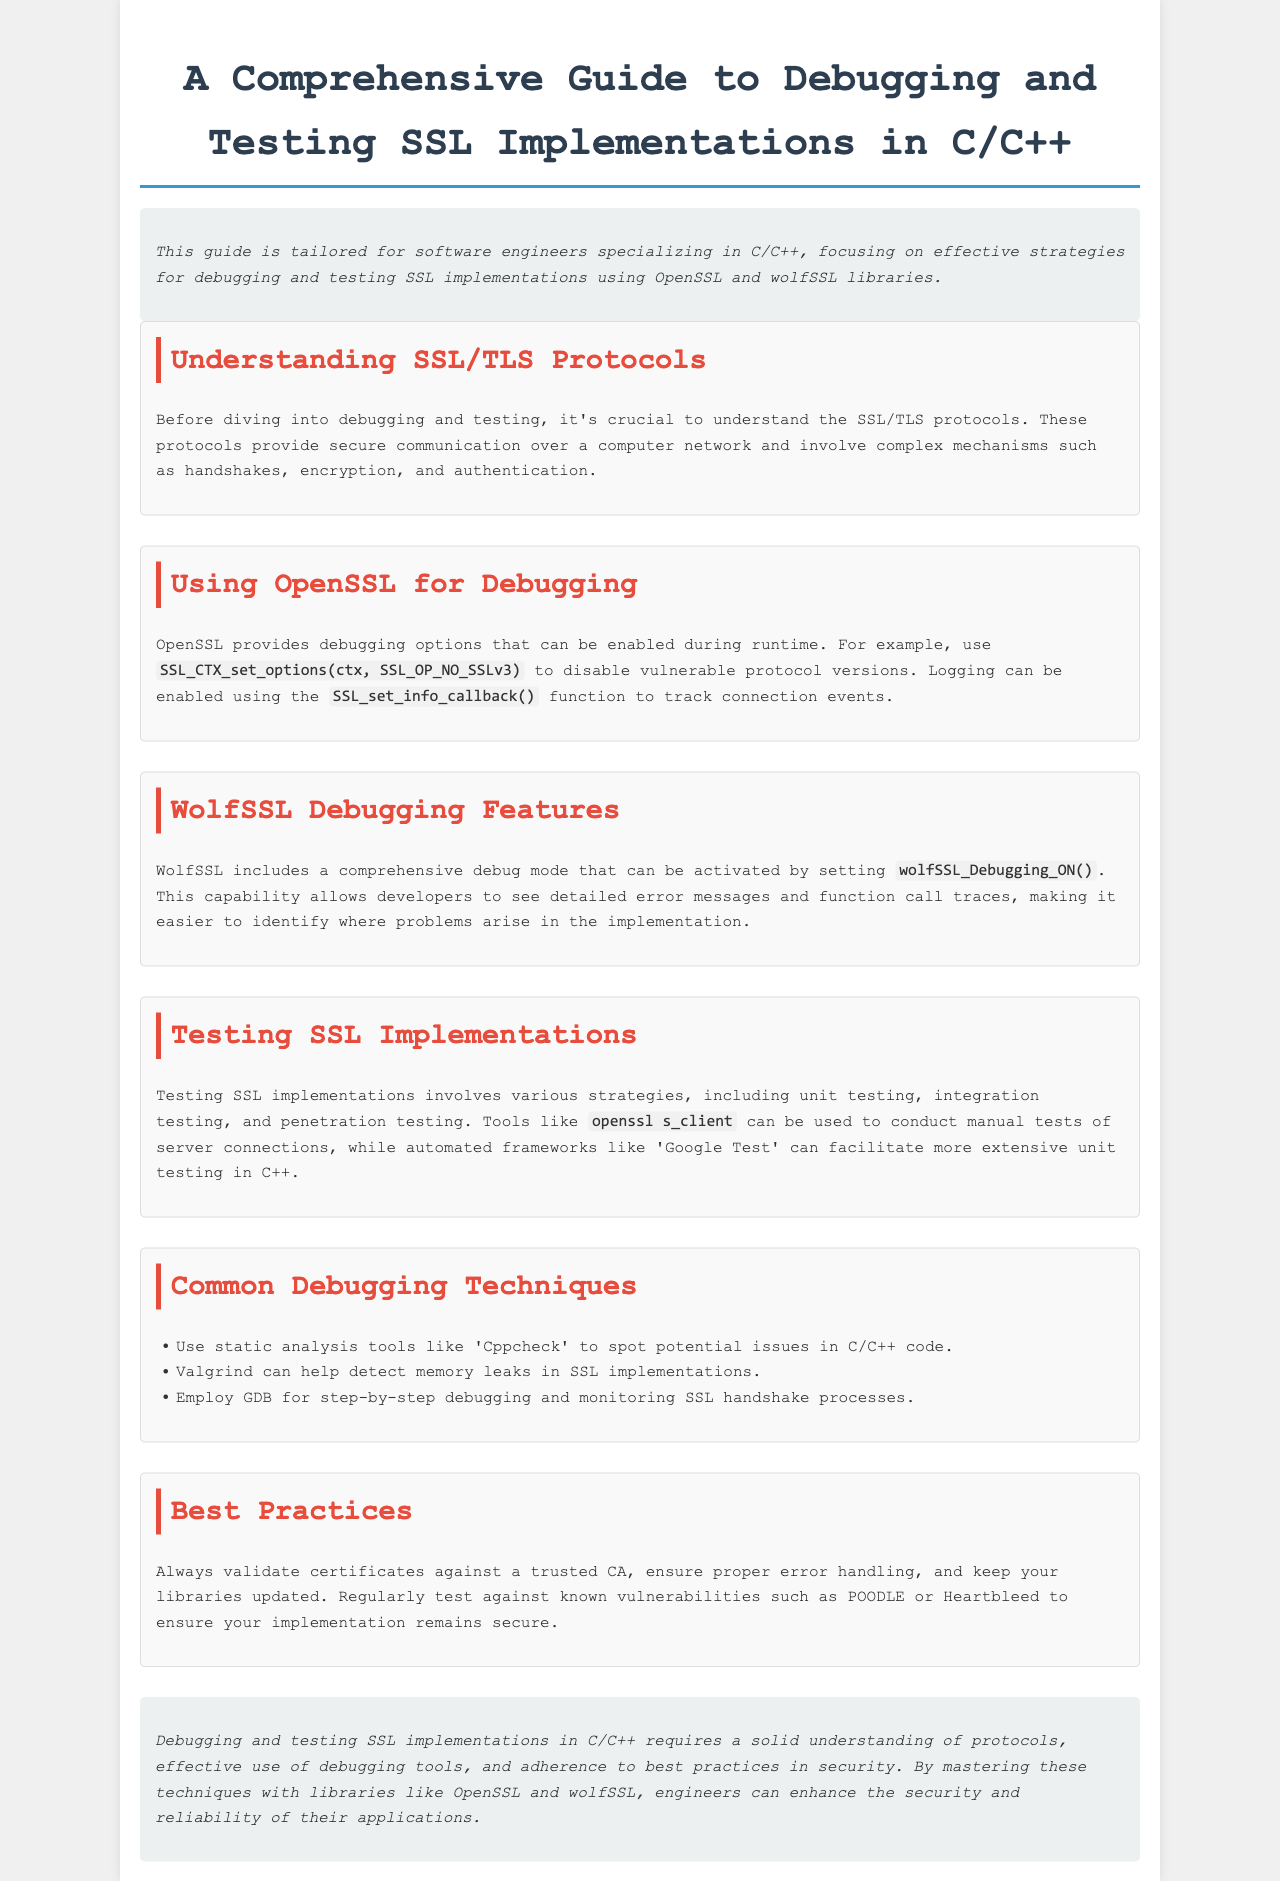what is the title of the guide? The title of the guide is stated prominently at the beginning of the document.
Answer: A Comprehensive Guide to Debugging and Testing SSL Implementations in C/C++ what libraries are focused on in this guide? The libraries mentioned for debugging and testing SSL implementations are noted in the introduction.
Answer: OpenSSL and wolfSSL what debugging function is used in OpenSSL? The document specifies a function related to debugging in OpenSSL.
Answer: SSL_set_info_callback() what command is used to test server connections? The guide mentions a particular command for testing SSL implementations.
Answer: openssl s_client which tools can detect memory leaks? The document lists tools for various testing purposes, including memory leak detection.
Answer: Valgrind what is a key recommendation for validating certificates? The best practices section provides specific advice regarding certificate validation.
Answer: against a trusted CA how can wolfSSL debugging mode be activated? The guide explains how to enable debugging features for wolfSSL.
Answer: wolfSSL_Debugging_ON() which testing strategy is considered more extensive in the document? The section on testing SSL implementations describes different strategies, focusing on one for extensive testing.
Answer: automated frameworks like 'Google Test' what common issue should be regularly tested against? The document references known vulnerabilities that should be tested.
Answer: POODLE or Heartbleed what tool can be used for static analysis in C/C++ code? The common debugging techniques section mentions tools for analyzing code.
Answer: Cppcheck 